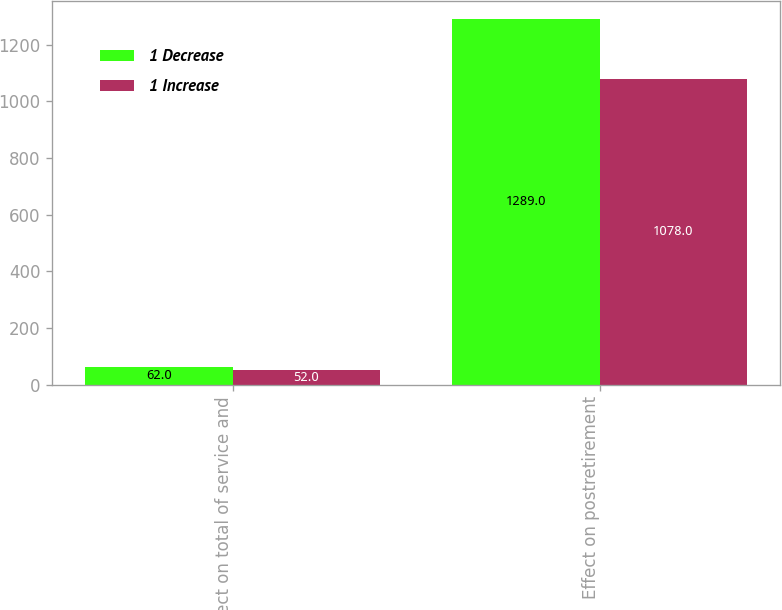Convert chart. <chart><loc_0><loc_0><loc_500><loc_500><stacked_bar_chart><ecel><fcel>Effect on total of service and<fcel>Effect on postretirement<nl><fcel>1 Decrease<fcel>62<fcel>1289<nl><fcel>1 Increase<fcel>52<fcel>1078<nl></chart> 